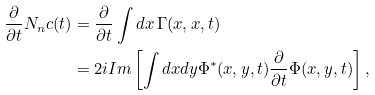Convert formula to latex. <formula><loc_0><loc_0><loc_500><loc_500>\frac { \partial } { \partial t } N _ { n } c ( t ) & = \frac { \partial } { \partial t } \int d x \, \Gamma ( x , x , t ) \\ & = 2 i I m \left [ \int d x d y \Phi ^ { * } ( x , y , t ) \frac { \partial } { \partial t } \Phi ( x , y , t ) \right ] ,</formula> 